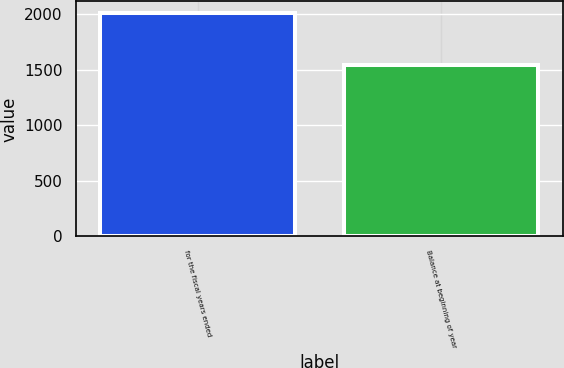<chart> <loc_0><loc_0><loc_500><loc_500><bar_chart><fcel>for the fiscal years ended<fcel>Balance at beginning of year<nl><fcel>2013<fcel>1540.8<nl></chart> 